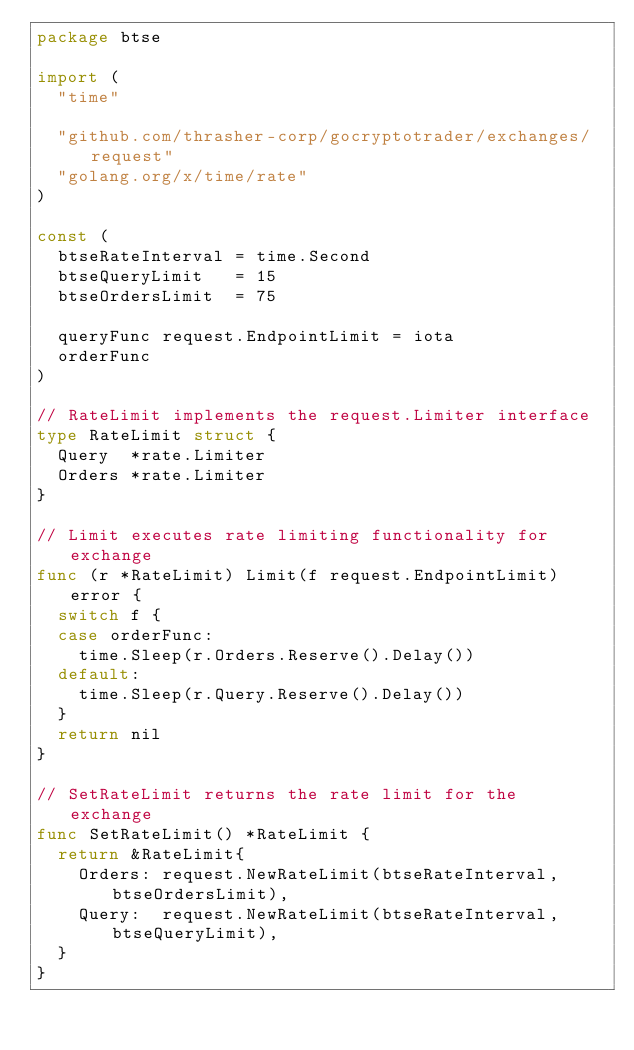Convert code to text. <code><loc_0><loc_0><loc_500><loc_500><_Go_>package btse

import (
	"time"

	"github.com/thrasher-corp/gocryptotrader/exchanges/request"
	"golang.org/x/time/rate"
)

const (
	btseRateInterval = time.Second
	btseQueryLimit   = 15
	btseOrdersLimit  = 75

	queryFunc request.EndpointLimit = iota
	orderFunc
)

// RateLimit implements the request.Limiter interface
type RateLimit struct {
	Query  *rate.Limiter
	Orders *rate.Limiter
}

// Limit executes rate limiting functionality for exchange
func (r *RateLimit) Limit(f request.EndpointLimit) error {
	switch f {
	case orderFunc:
		time.Sleep(r.Orders.Reserve().Delay())
	default:
		time.Sleep(r.Query.Reserve().Delay())
	}
	return nil
}

// SetRateLimit returns the rate limit for the exchange
func SetRateLimit() *RateLimit {
	return &RateLimit{
		Orders: request.NewRateLimit(btseRateInterval, btseOrdersLimit),
		Query:  request.NewRateLimit(btseRateInterval, btseQueryLimit),
	}
}
</code> 